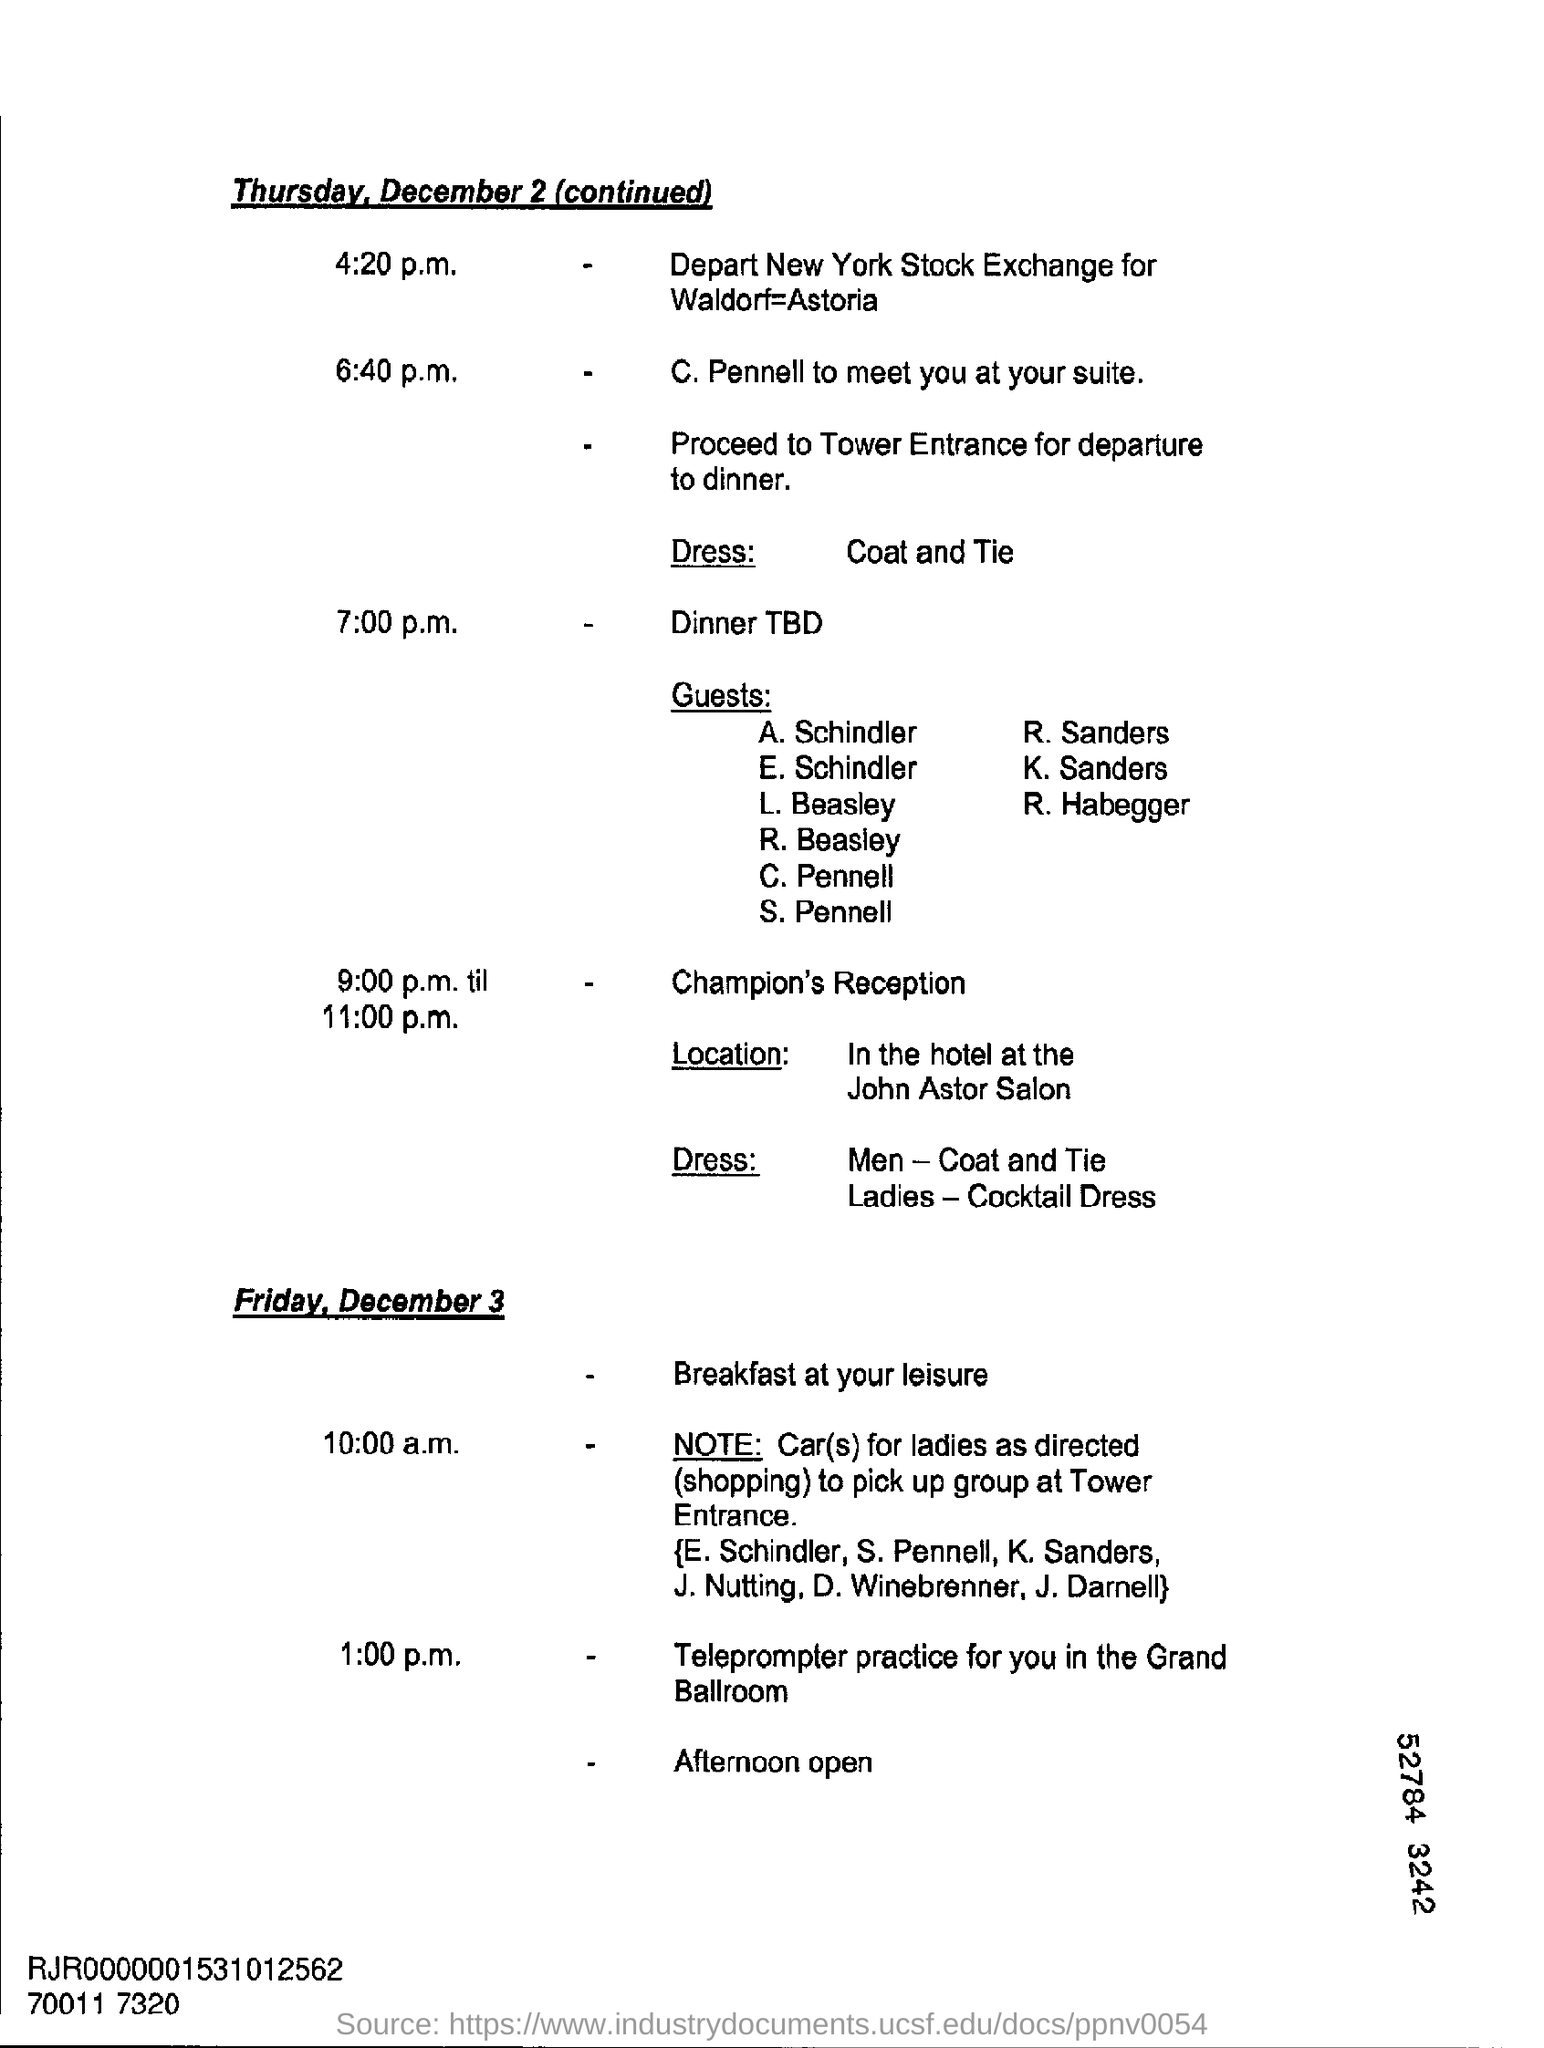Outline some significant characteristics in this image. On December 2, Thursday will occur. 